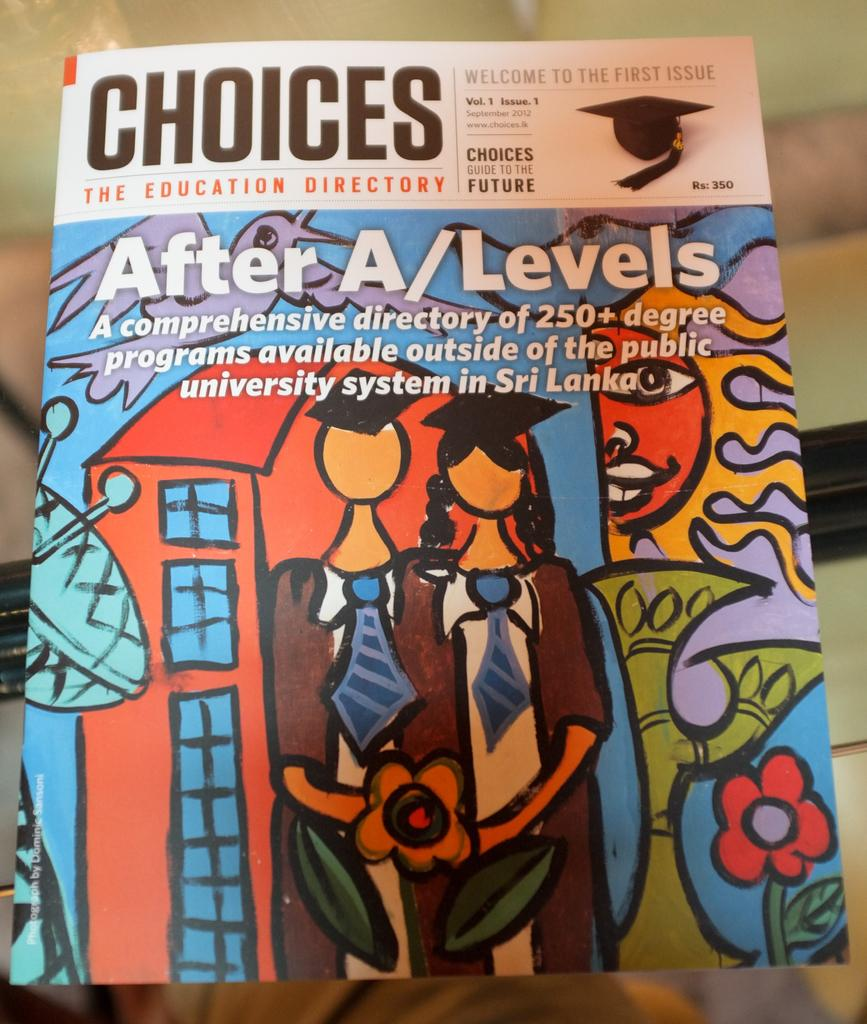What is featured on the poster in the image? The poster contains paintings and text. What types of paintings are on the poster? There is a sun painting and a flower painting on the poster. Are there any figures depicted in the paintings? Yes, there is a picture of two persons on the poster. What type of education is being offered by the queen in the image? There is no queen or education mentioned in the image; it only features a poster with paintings and text. 